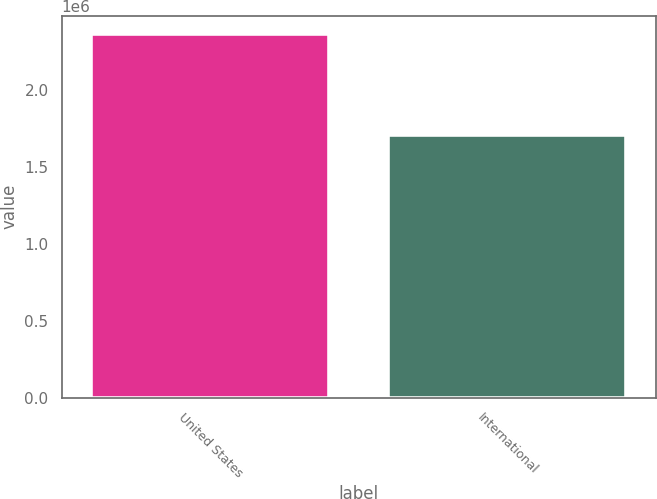<chart> <loc_0><loc_0><loc_500><loc_500><bar_chart><fcel>United States<fcel>International<nl><fcel>2.36356e+06<fcel>1.70439e+06<nl></chart> 